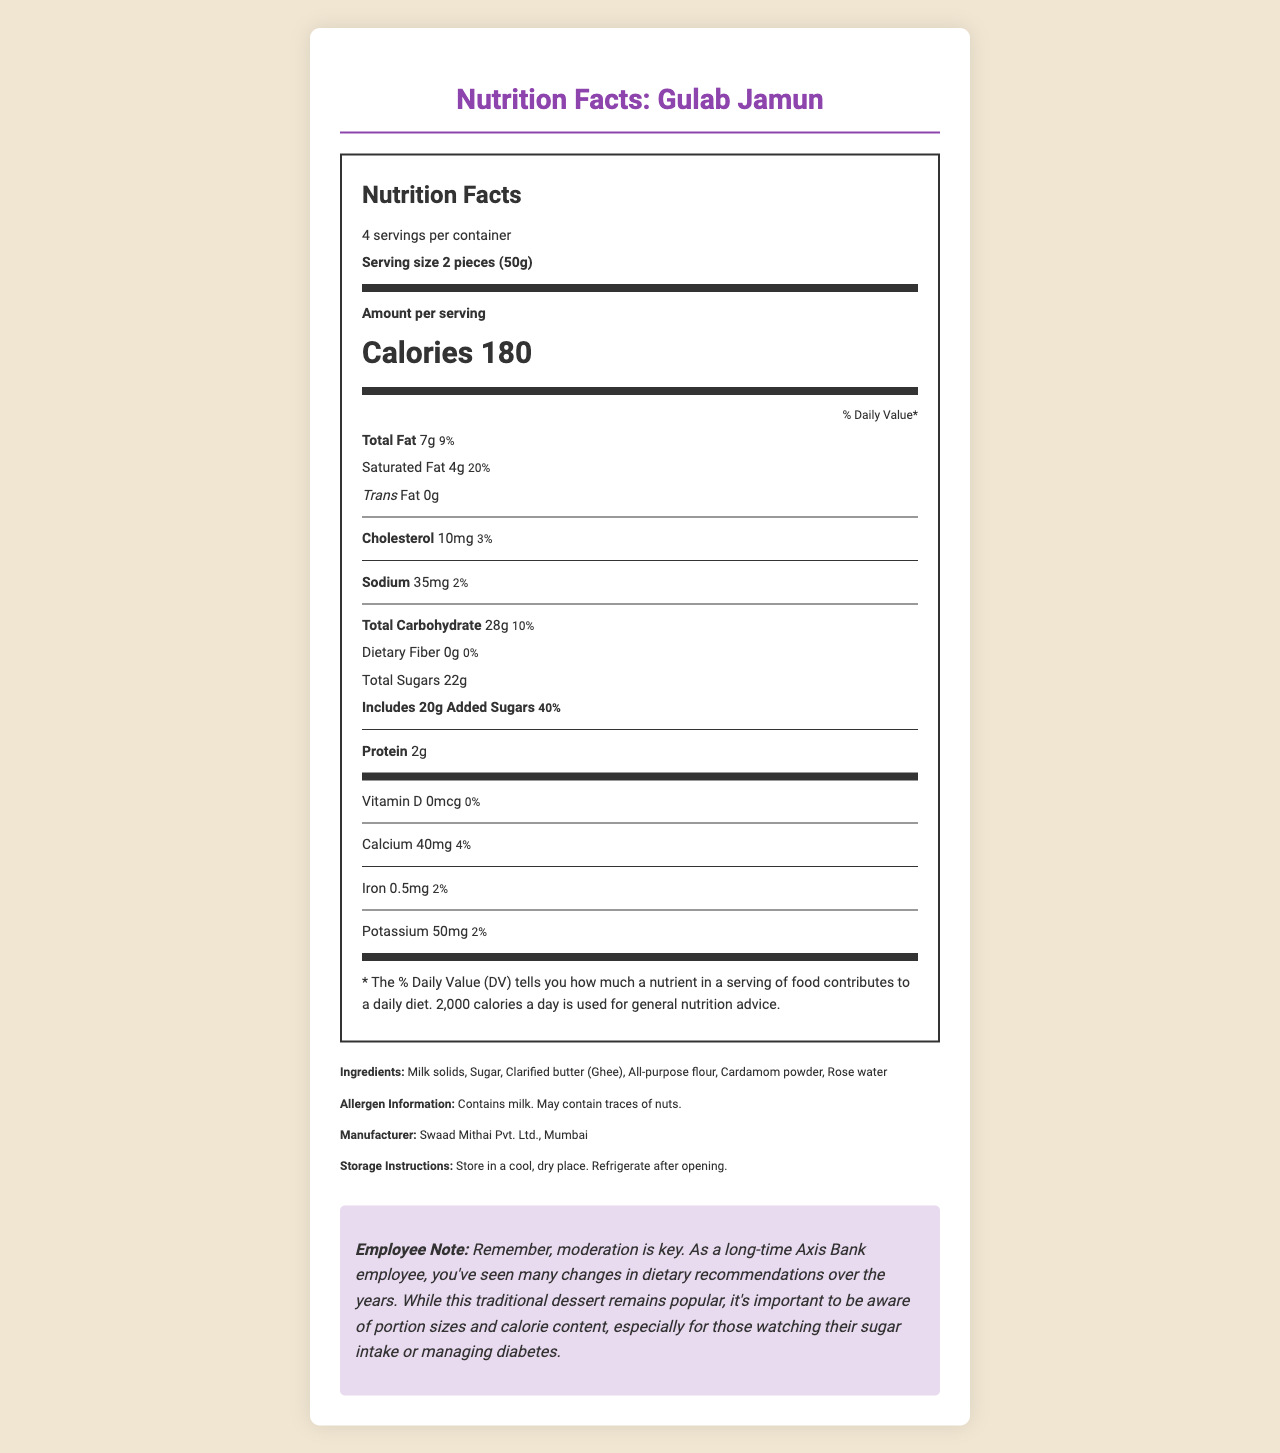what is the serving size? The serving size is explicitly mentioned as "2 pieces (50g)" in the nutrition label section of the document.
Answer: 2 pieces (50g) how many calories are in one serving? One serving of Gulab Jamun contains 180 calories, as noted in the bold section detailing "Calories 180."
Answer: 180 how much total fat is in a serving? The document states that each serving contains 7g of total fat.
Answer: 7g what is the percentage daily value of saturated fat per serving? The daily value for saturated fat is given as 20% next to the amount "4g."
Answer: 20% how many grams of added sugars are there per serving? The document lists "Includes 20g Added Sugars" under the total carbohydrate section.
Answer: 20g what is the recommended storage condition for this product? The proper storage conditions are clearly provided in the storage instructions section of the document.
Answer: Store in a cool, dry place. Refrigerate after opening. which vitamin has a daily value percentage of 0% in this product? A. Vitamin D B. Calcium C. Iron D. Potassium Vitamin D has a daily value of 0%, as indicated in the vitamin and mineral information section.
Answer: A how many servings are there in a container? A. 2 B. 4 C. 6 D. 8 The document specifies that there are 4 servings per container.
Answer: B is there any dietary fiber in a serving of this dessert? The dietary fiber content is listed as 0g, with a daily value of 0%.
Answer: No describe the main idea of this document. The document comprehensively outlines various nutritional aspects and other relevant details regarding the Gulab Jamun dessert, along with specific advice for monitoring dietary intake.
Answer: This document provides detailed nutritional information for Gulab Jamun, including serving size, calorie content, macronutrients, vitamins, and minerals. It also includes ingredient lists, allergen information, manufacturer details, and storage instructions. Additionally, there is a note reminding employees about the importance of moderation in consumption. how much calcium does one serving contain? The document states that one serving of Gulab Jamun contains 40mg of calcium.
Answer: 40mg what is the daily value percentage of sodium per serving? Each serving has a daily value percentage of 2% for sodium, as noted next to the sodium amount of 35mg.
Answer: 2% which ingredient is not listed in this document? A. Milk solids B. Sugar C. Almonds D. Cardamom powder Almonds are not listed among the ingredients; the listed ingredients include milk solids, sugar, clarified butter (ghee), all-purpose flour, cardamom powder, and rose water.
Answer: C can you determine the amount of Vitamin C in this dessert? The document does not provide any information regarding the Vitamin C content.
Answer: Not enough information 